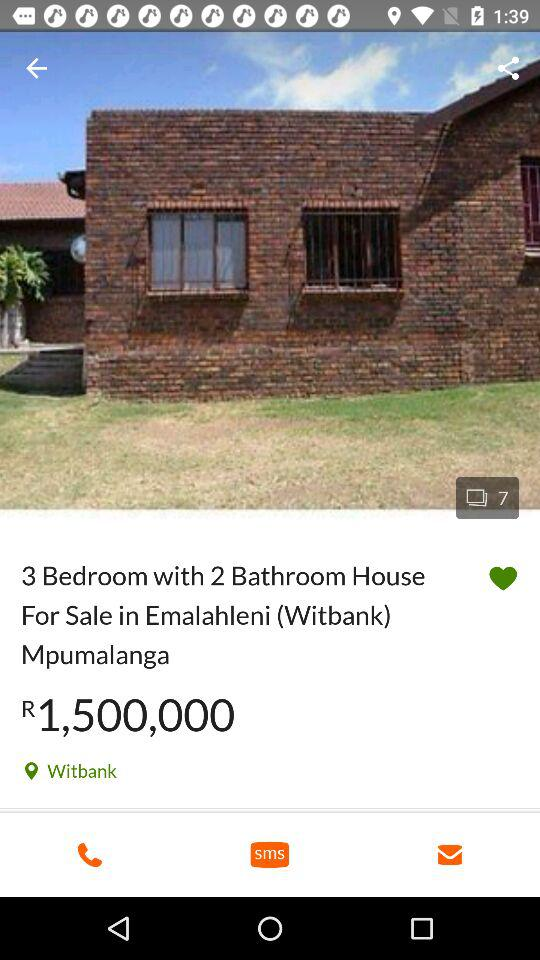What is the price of the "3 Bedroom with 2 Bathroom House"? The price is R1,500,000. 